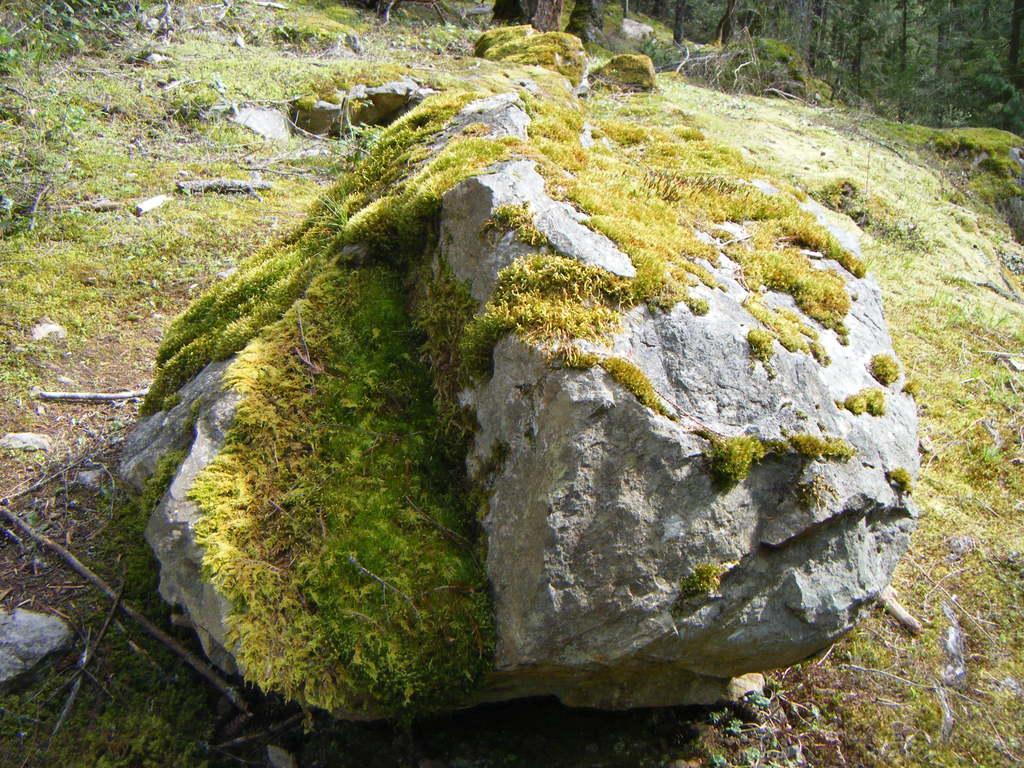Can you describe this image briefly? In this image we can see a rock, and grass on it, there are trees at the back, there are dried twigs and leaves on the ground. 